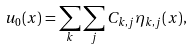<formula> <loc_0><loc_0><loc_500><loc_500>u _ { 0 } ( x ) = \sum _ { k } \sum _ { j } C _ { k , j } \eta _ { k , j } ( x ) ,</formula> 